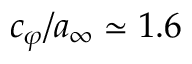Convert formula to latex. <formula><loc_0><loc_0><loc_500><loc_500>c _ { \varphi } / a _ { \infty } \simeq 1 . 6</formula> 